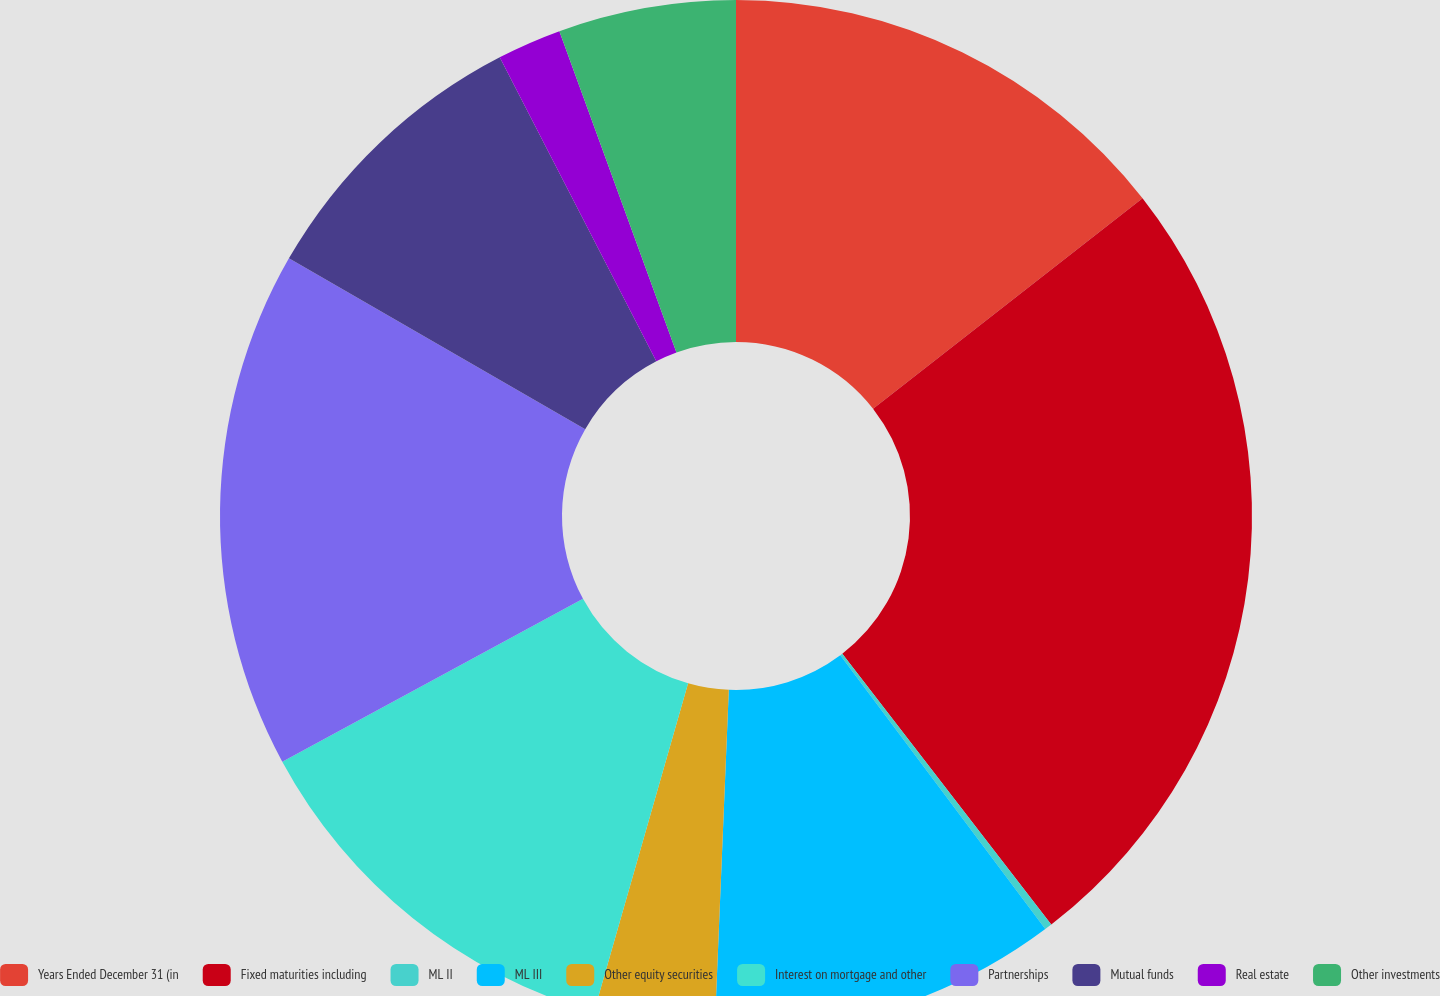Convert chart. <chart><loc_0><loc_0><loc_500><loc_500><pie_chart><fcel>Years Ended December 31 (in<fcel>Fixed maturities including<fcel>ML II<fcel>ML III<fcel>Other equity securities<fcel>Interest on mortgage and other<fcel>Partnerships<fcel>Mutual funds<fcel>Real estate<fcel>Other investments<nl><fcel>14.44%<fcel>25.1%<fcel>0.23%<fcel>10.89%<fcel>3.78%<fcel>12.66%<fcel>16.22%<fcel>9.11%<fcel>2.01%<fcel>5.56%<nl></chart> 